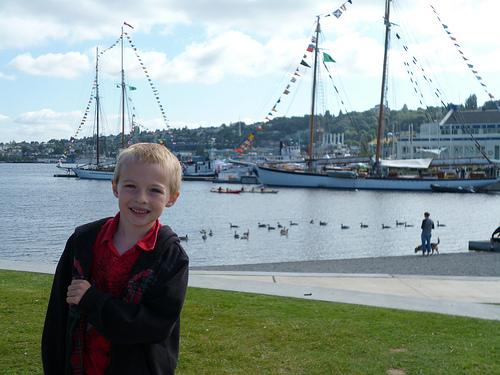What can you see in the background of the picture? In the background, there is a large building across the lake and a thin white tower on a hill. Describe the vessels on the water in the image. There are sailing ships decorated with multi-colored banners, a red kayak, and canoes on the water. What is happening near the water's edge in the image? A person with a dog is standing at the water's edge, and ducks are swimming nearby. Provide a brief description of the dominant human figure in the image. A young boy with blonde hair wearing a red shirt and black coat is posing for a picture. List the different types of waterfowl and animals observed in the scene. There are ducks in the water and a dog near the water's edge. Describe the boy's facial features in the image. The boy's face has blonde hair, a visible right shirt collar, and a distinct nose. Mention the interaction between the person and the animal in the scene. A man and his dog can be seen standing together near the water at the marina. Mention the various types of watercraft in the image. Sailing ships with colorful flags, a red kayak, and canoes can be seen in the water. Identify any flags or decorations on the sailing ships. The sailing ships have multi-colored banners and a small green flag near their tops. Give a description of the boy's attire and appearance in the image. The boy has blonde hair, and he's wearing a red shirt with a long-sleeved dark-colored coat. 